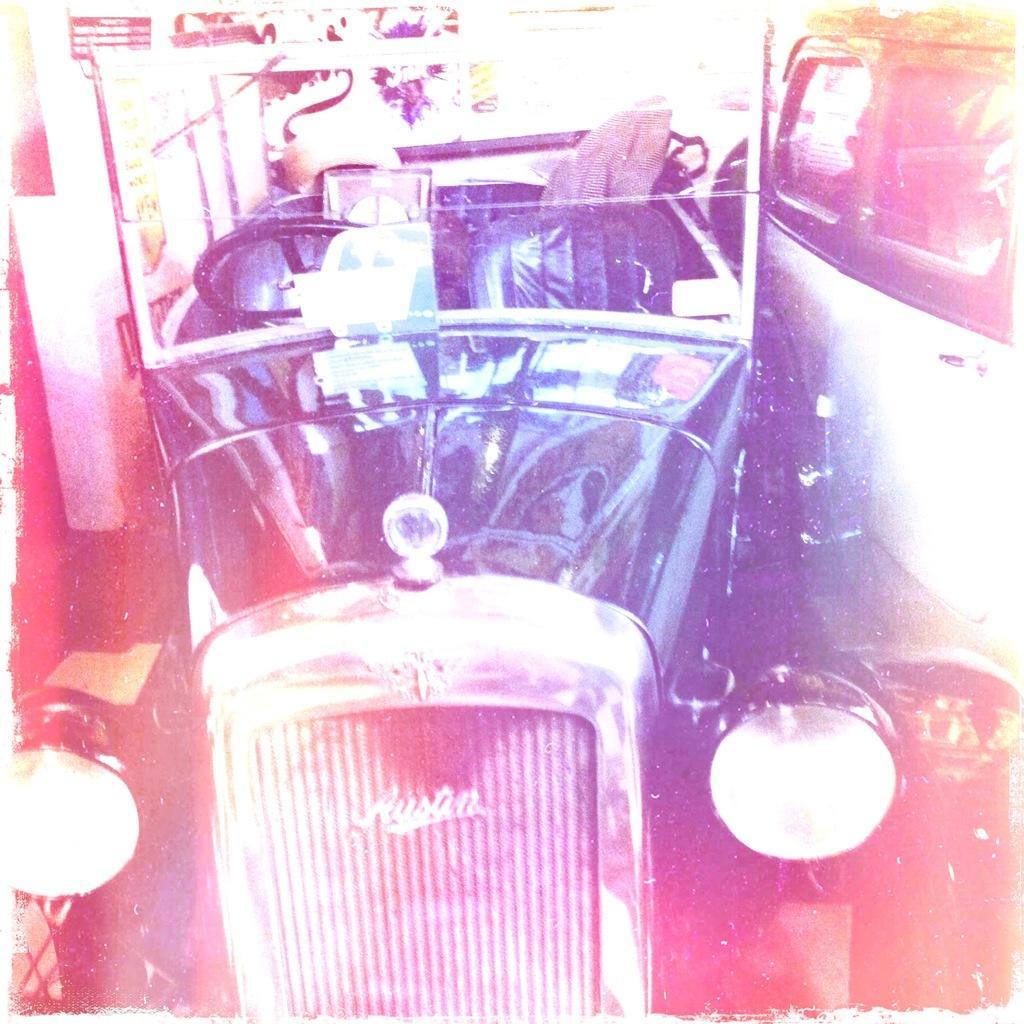Could you give a brief overview of what you see in this image? In this image I can see a vehicle in black color. I can also see the other vehicle in white color and I can see white color background. 